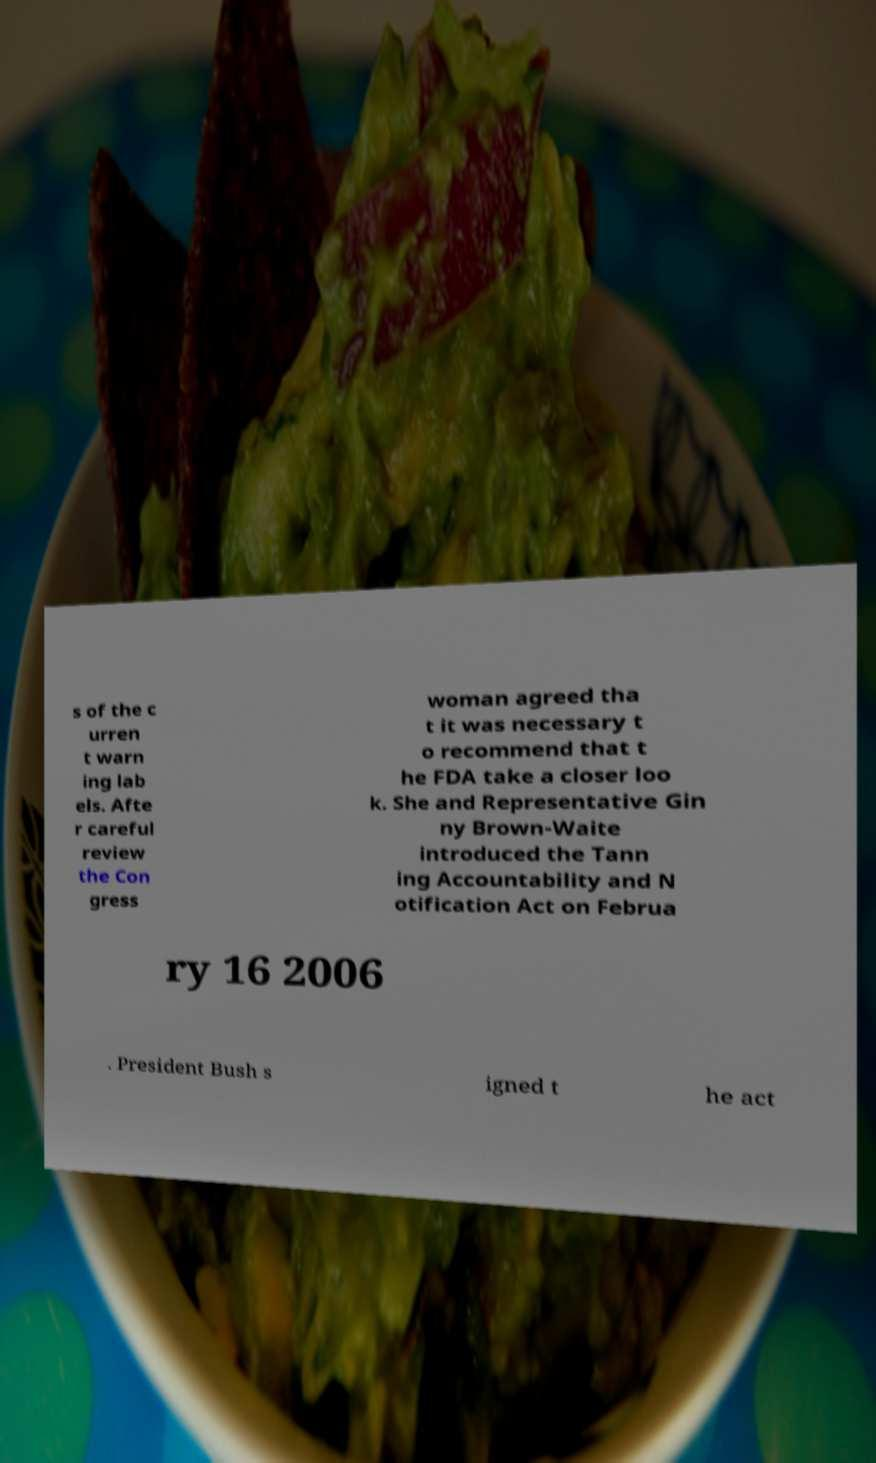There's text embedded in this image that I need extracted. Can you transcribe it verbatim? s of the c urren t warn ing lab els. Afte r careful review the Con gress woman agreed tha t it was necessary t o recommend that t he FDA take a closer loo k. She and Representative Gin ny Brown-Waite introduced the Tann ing Accountability and N otification Act on Februa ry 16 2006 . President Bush s igned t he act 